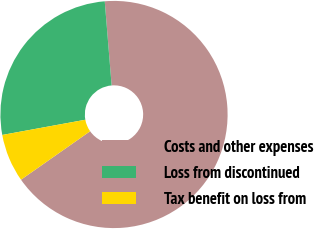Convert chart to OTSL. <chart><loc_0><loc_0><loc_500><loc_500><pie_chart><fcel>Costs and other expenses<fcel>Loss from discontinued<fcel>Tax benefit on loss from<nl><fcel>66.56%<fcel>26.58%<fcel>6.85%<nl></chart> 